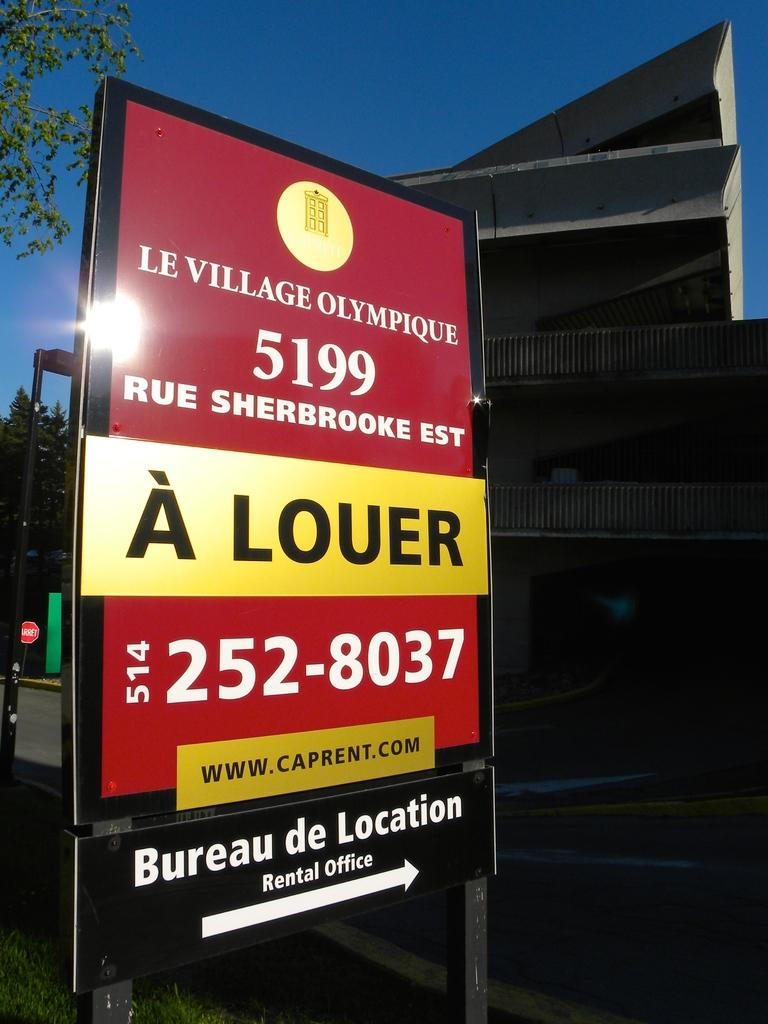<image>
Offer a succinct explanation of the picture presented. a rental office at Bureau De Location is shown on a sign 